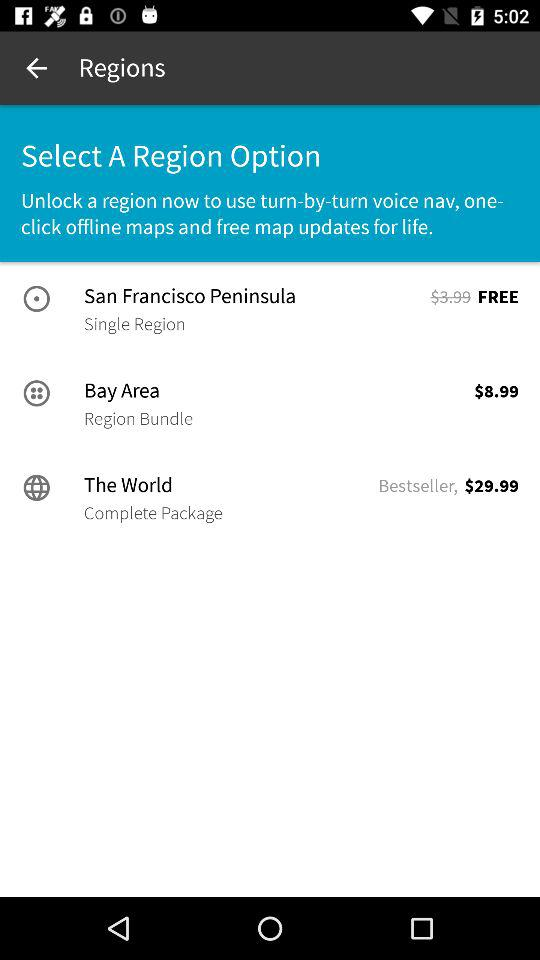Which region is the most expensive?
Answer the question using a single word or phrase. The World 